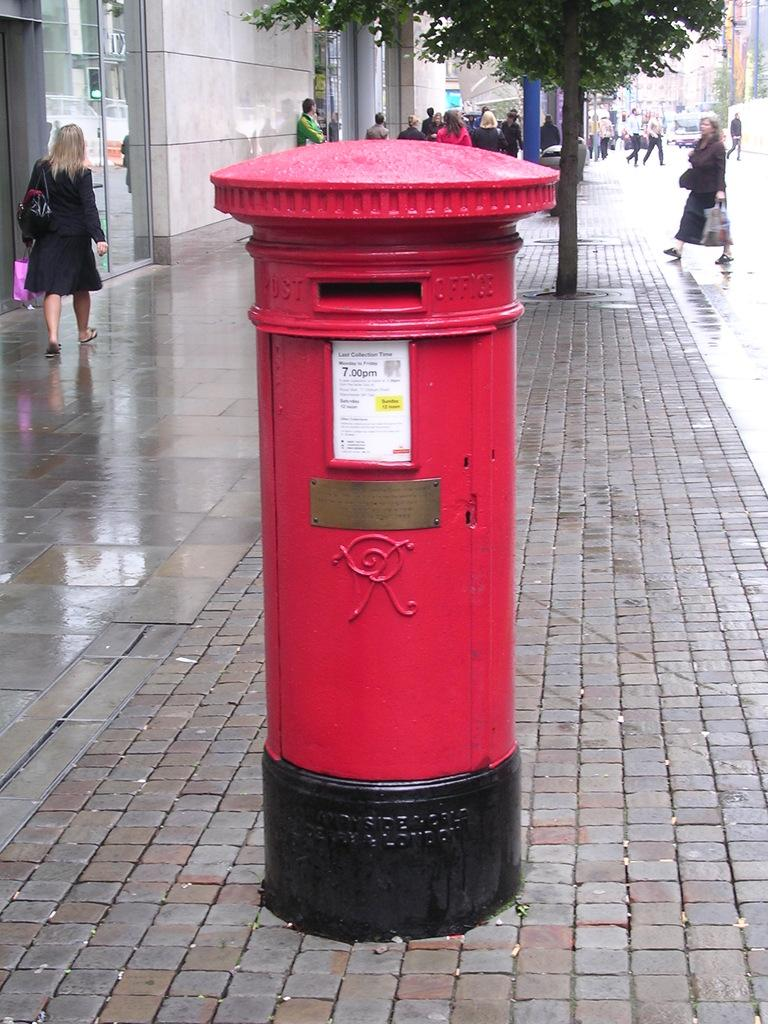What object is located on the road in the image? There is a post box on the road in the image. What is situated behind the post box? There is a plant behind the post box. What activity are people engaged in on the road? People are walking on the road. What structure is located beside the post box? There is a building beside the post box. How many tomatoes are hanging from the building beside the post box? There are no tomatoes visible in the image; the building is beside the post box, but no tomatoes are present. What is the governor doing in the image? There is no governor present in the image, so it is not possible to determine what the governor might be doing. 